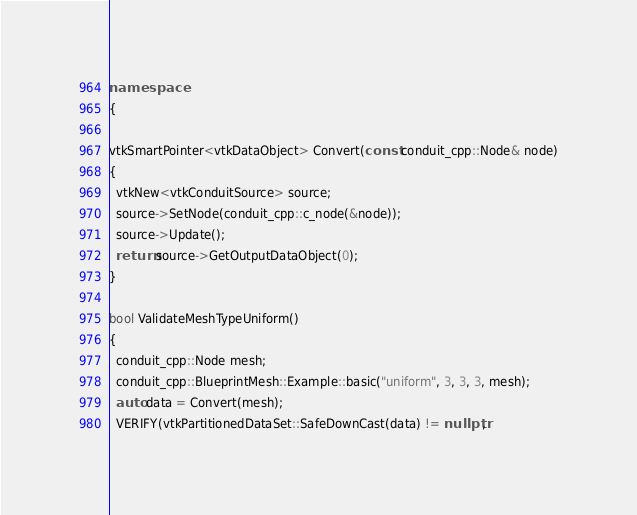Convert code to text. <code><loc_0><loc_0><loc_500><loc_500><_C++_>
namespace
{

vtkSmartPointer<vtkDataObject> Convert(const conduit_cpp::Node& node)
{
  vtkNew<vtkConduitSource> source;
  source->SetNode(conduit_cpp::c_node(&node));
  source->Update();
  return source->GetOutputDataObject(0);
}

bool ValidateMeshTypeUniform()
{
  conduit_cpp::Node mesh;
  conduit_cpp::BlueprintMesh::Example::basic("uniform", 3, 3, 3, mesh);
  auto data = Convert(mesh);
  VERIFY(vtkPartitionedDataSet::SafeDownCast(data) != nullptr,</code> 